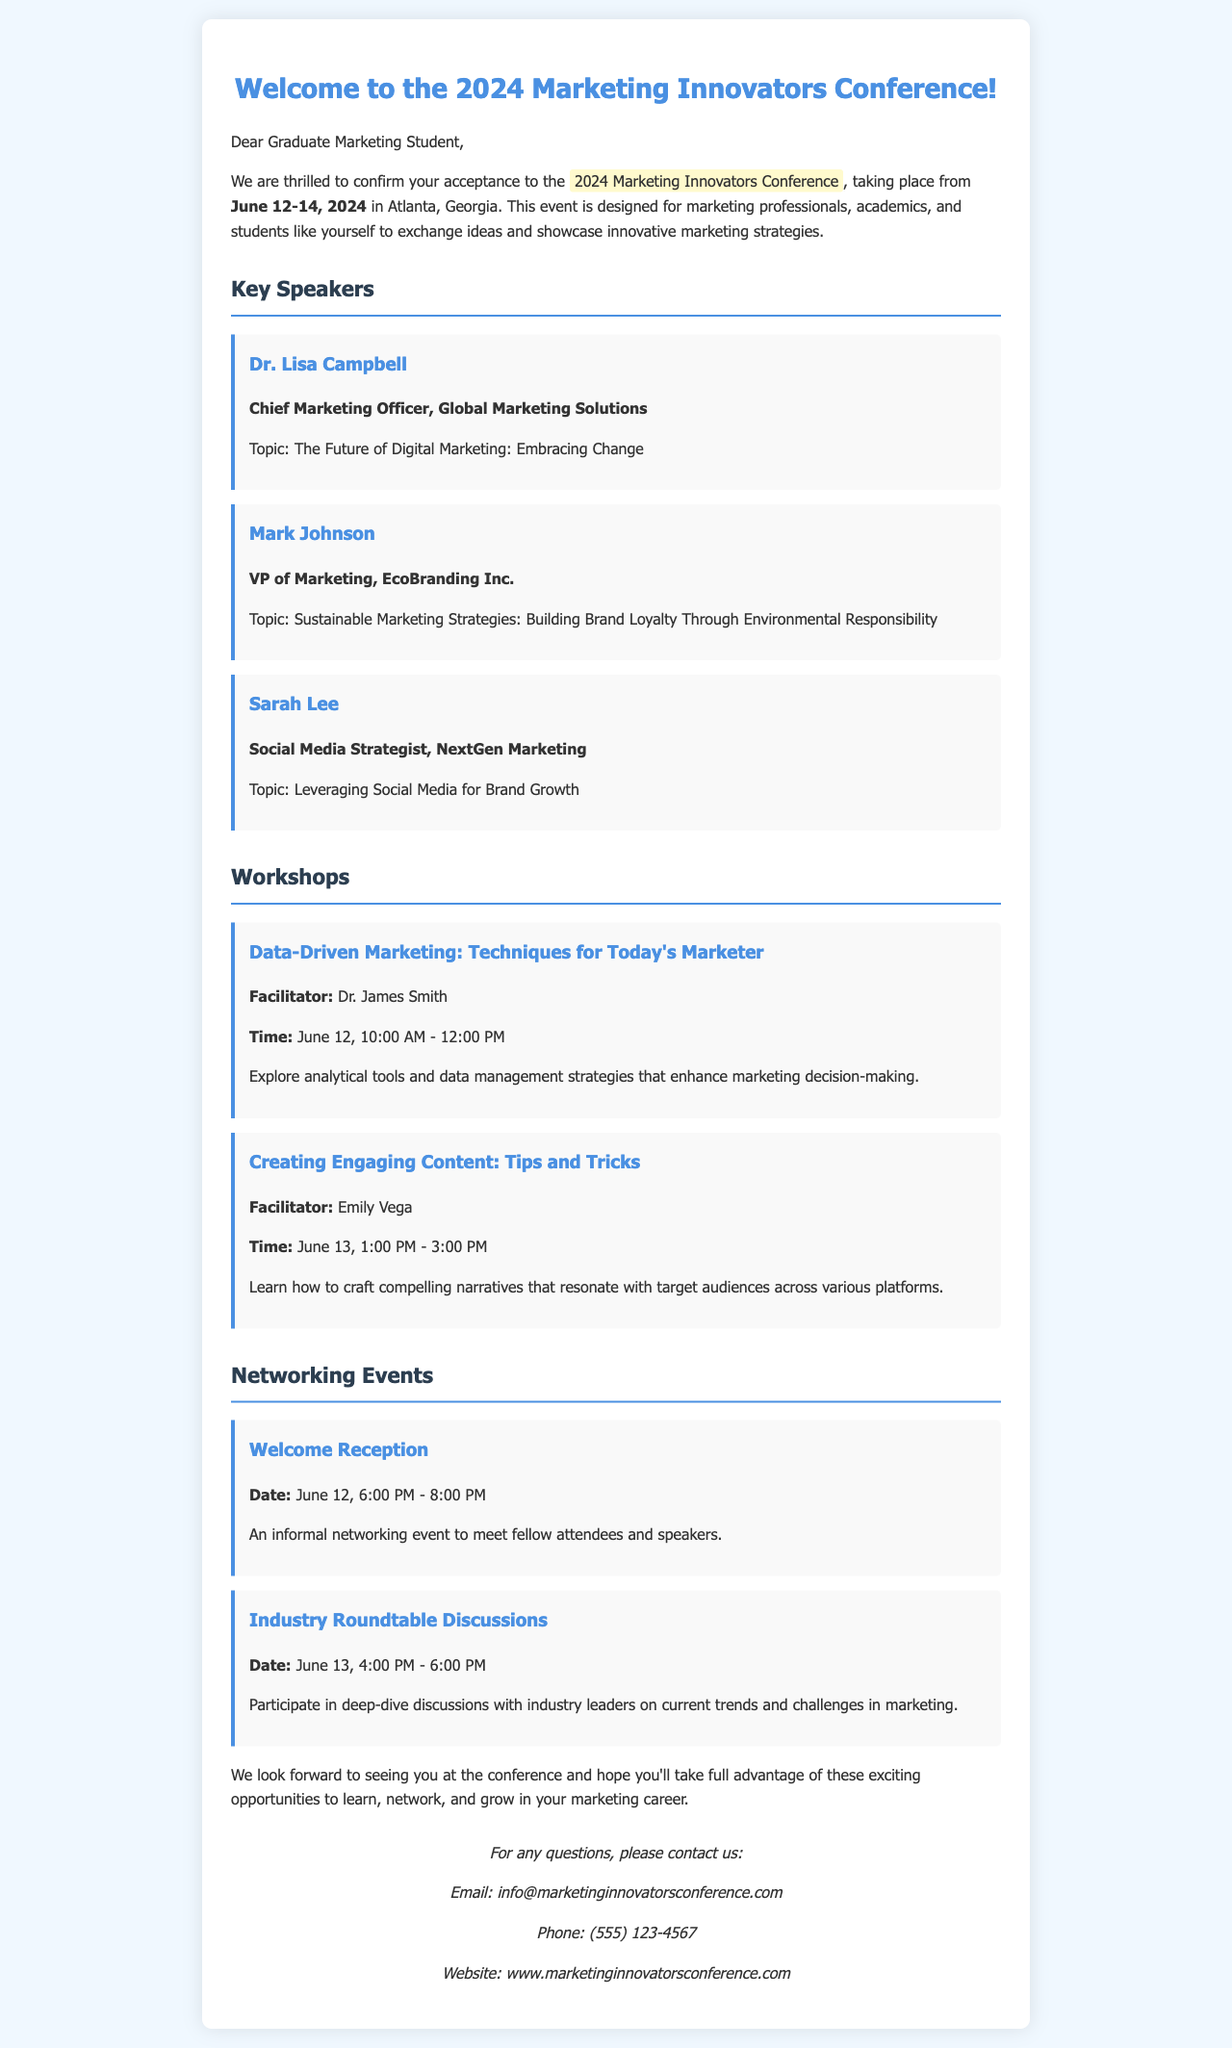What are the dates of the conference? The dates of the conference are explicitly mentioned in the document, which states it takes place from June 12-14, 2024.
Answer: June 12-14, 2024 Who is the Chief Marketing Officer speaker? The document lists Dr. Lisa Campbell as the Chief Marketing Officer and provides her associated topic.
Answer: Dr. Lisa Campbell What workshop is scheduled for June 13? The document includes a list of workshops, with "Creating Engaging Content: Tips and Tricks" scheduled on June 13.
Answer: Creating Engaging Content: Tips and Tricks What is the time for the "Data-Driven Marketing" workshop? The workshop's time is specified in the document along with the date.
Answer: June 12, 10:00 AM - 12:00 PM How long is the Welcome Reception? The document indicates the duration of the Welcome Reception, stating it lasts for 2 hours.
Answer: 2 hours What is the main purpose of the conference? The document describes the purpose of the conference as an event for marketing professionals, academics, and students to exchange ideas and showcase strategies.
Answer: Exchange ideas and showcase strategies What is the contact email provided in the letter? The displayed document provides a specific email address for contact inquiries.
Answer: info@marketinginnovatorsconference.com Who is the facilitator for the "Creating Engaging Content" workshop? The document lists Emily Vega as the facilitator of this particular workshop.
Answer: Emily Vega 